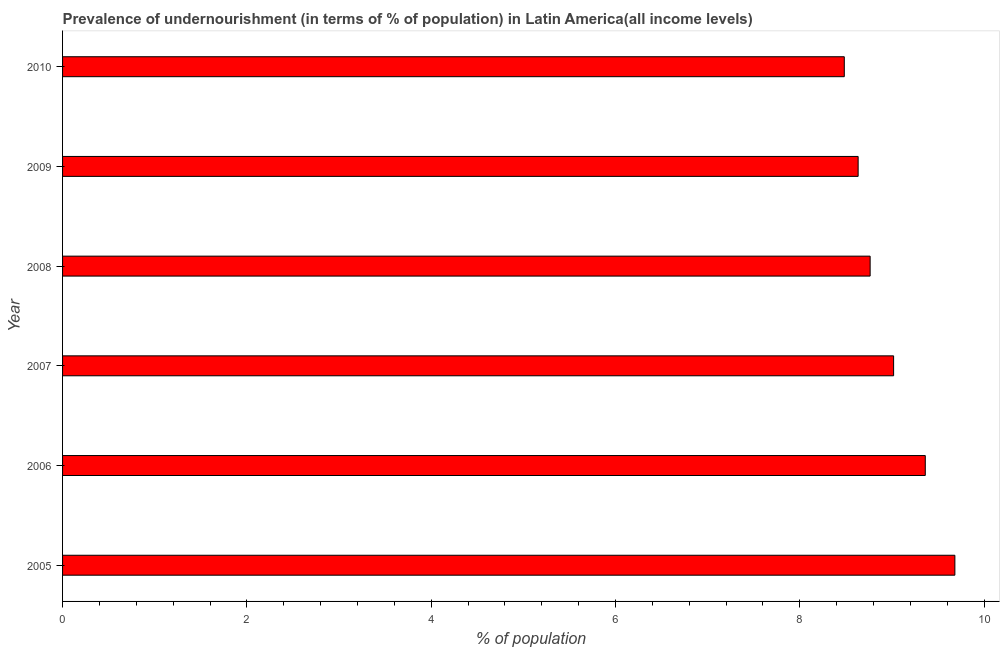Does the graph contain any zero values?
Ensure brevity in your answer.  No. Does the graph contain grids?
Ensure brevity in your answer.  No. What is the title of the graph?
Ensure brevity in your answer.  Prevalence of undernourishment (in terms of % of population) in Latin America(all income levels). What is the label or title of the X-axis?
Offer a very short reply. % of population. What is the label or title of the Y-axis?
Keep it short and to the point. Year. What is the percentage of undernourished population in 2008?
Give a very brief answer. 8.76. Across all years, what is the maximum percentage of undernourished population?
Give a very brief answer. 9.68. Across all years, what is the minimum percentage of undernourished population?
Offer a very short reply. 8.48. In which year was the percentage of undernourished population maximum?
Your response must be concise. 2005. In which year was the percentage of undernourished population minimum?
Make the answer very short. 2010. What is the sum of the percentage of undernourished population?
Your answer should be compact. 53.94. What is the difference between the percentage of undernourished population in 2005 and 2008?
Make the answer very short. 0.92. What is the average percentage of undernourished population per year?
Your answer should be very brief. 8.99. What is the median percentage of undernourished population?
Make the answer very short. 8.89. Do a majority of the years between 2006 and 2010 (inclusive) have percentage of undernourished population greater than 4.4 %?
Your answer should be very brief. Yes. What is the ratio of the percentage of undernourished population in 2008 to that in 2010?
Provide a succinct answer. 1.03. Is the percentage of undernourished population in 2007 less than that in 2010?
Your response must be concise. No. What is the difference between the highest and the second highest percentage of undernourished population?
Ensure brevity in your answer.  0.32. Is the sum of the percentage of undernourished population in 2005 and 2007 greater than the maximum percentage of undernourished population across all years?
Offer a very short reply. Yes. What is the difference between the highest and the lowest percentage of undernourished population?
Ensure brevity in your answer.  1.2. Are all the bars in the graph horizontal?
Offer a very short reply. Yes. How many years are there in the graph?
Your response must be concise. 6. What is the difference between two consecutive major ticks on the X-axis?
Your response must be concise. 2. Are the values on the major ticks of X-axis written in scientific E-notation?
Give a very brief answer. No. What is the % of population in 2005?
Your answer should be very brief. 9.68. What is the % of population in 2006?
Your answer should be compact. 9.36. What is the % of population in 2007?
Your answer should be compact. 9.02. What is the % of population of 2008?
Ensure brevity in your answer.  8.76. What is the % of population of 2009?
Ensure brevity in your answer.  8.63. What is the % of population of 2010?
Your response must be concise. 8.48. What is the difference between the % of population in 2005 and 2006?
Offer a terse response. 0.32. What is the difference between the % of population in 2005 and 2007?
Provide a succinct answer. 0.66. What is the difference between the % of population in 2005 and 2008?
Your answer should be compact. 0.92. What is the difference between the % of population in 2005 and 2009?
Give a very brief answer. 1.05. What is the difference between the % of population in 2005 and 2010?
Your answer should be very brief. 1.2. What is the difference between the % of population in 2006 and 2007?
Make the answer very short. 0.34. What is the difference between the % of population in 2006 and 2008?
Offer a very short reply. 0.6. What is the difference between the % of population in 2006 and 2009?
Provide a succinct answer. 0.73. What is the difference between the % of population in 2006 and 2010?
Provide a succinct answer. 0.88. What is the difference between the % of population in 2007 and 2008?
Offer a terse response. 0.25. What is the difference between the % of population in 2007 and 2009?
Offer a very short reply. 0.38. What is the difference between the % of population in 2007 and 2010?
Ensure brevity in your answer.  0.54. What is the difference between the % of population in 2008 and 2009?
Make the answer very short. 0.13. What is the difference between the % of population in 2008 and 2010?
Keep it short and to the point. 0.28. What is the difference between the % of population in 2009 and 2010?
Offer a terse response. 0.15. What is the ratio of the % of population in 2005 to that in 2006?
Provide a short and direct response. 1.03. What is the ratio of the % of population in 2005 to that in 2007?
Your response must be concise. 1.07. What is the ratio of the % of population in 2005 to that in 2008?
Your response must be concise. 1.1. What is the ratio of the % of population in 2005 to that in 2009?
Ensure brevity in your answer.  1.12. What is the ratio of the % of population in 2005 to that in 2010?
Make the answer very short. 1.14. What is the ratio of the % of population in 2006 to that in 2007?
Your answer should be very brief. 1.04. What is the ratio of the % of population in 2006 to that in 2008?
Give a very brief answer. 1.07. What is the ratio of the % of population in 2006 to that in 2009?
Your response must be concise. 1.08. What is the ratio of the % of population in 2006 to that in 2010?
Your answer should be compact. 1.1. What is the ratio of the % of population in 2007 to that in 2008?
Your response must be concise. 1.03. What is the ratio of the % of population in 2007 to that in 2009?
Give a very brief answer. 1.04. What is the ratio of the % of population in 2007 to that in 2010?
Your response must be concise. 1.06. What is the ratio of the % of population in 2008 to that in 2009?
Give a very brief answer. 1.01. What is the ratio of the % of population in 2008 to that in 2010?
Your answer should be compact. 1.03. What is the ratio of the % of population in 2009 to that in 2010?
Provide a short and direct response. 1.02. 